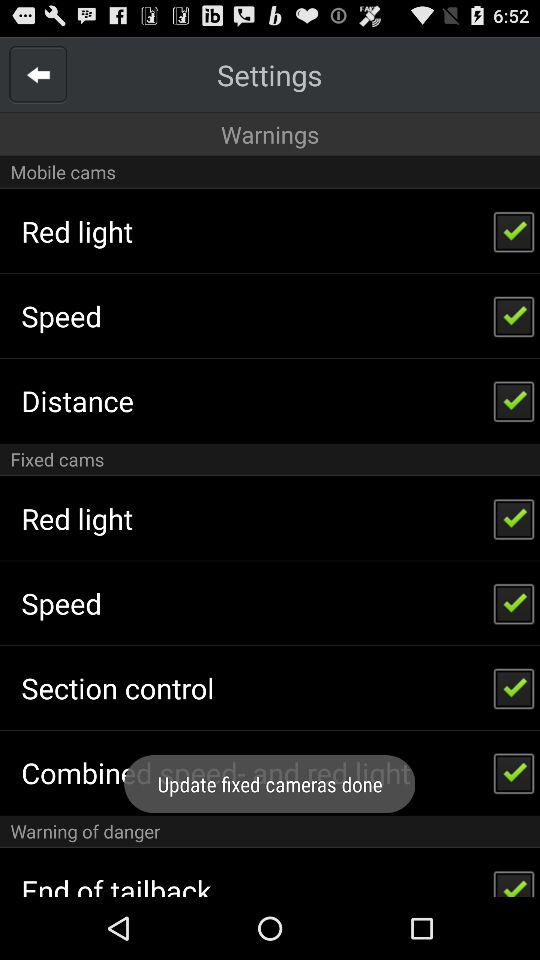What is the status of "Distance"? The status of "Distance" is "on". 